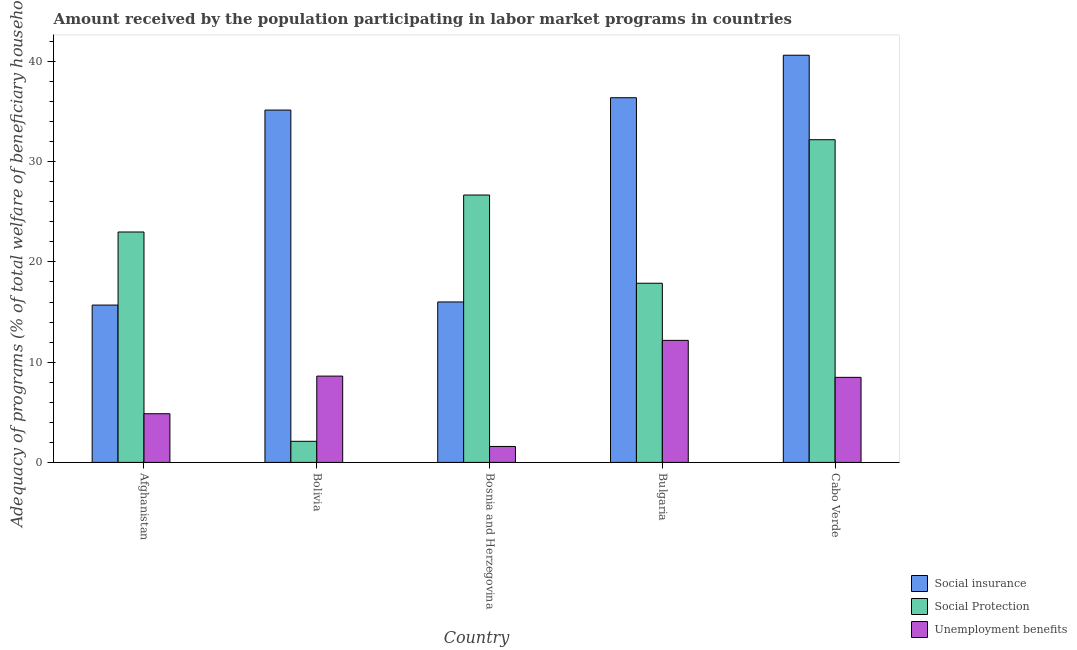Are the number of bars per tick equal to the number of legend labels?
Keep it short and to the point. Yes. How many bars are there on the 4th tick from the left?
Ensure brevity in your answer.  3. How many bars are there on the 1st tick from the right?
Ensure brevity in your answer.  3. What is the label of the 4th group of bars from the left?
Give a very brief answer. Bulgaria. What is the amount received by the population participating in social protection programs in Bulgaria?
Give a very brief answer. 17.87. Across all countries, what is the maximum amount received by the population participating in unemployment benefits programs?
Your answer should be compact. 12.17. Across all countries, what is the minimum amount received by the population participating in social protection programs?
Keep it short and to the point. 2.1. In which country was the amount received by the population participating in social protection programs maximum?
Give a very brief answer. Cabo Verde. In which country was the amount received by the population participating in social insurance programs minimum?
Give a very brief answer. Afghanistan. What is the total amount received by the population participating in social insurance programs in the graph?
Make the answer very short. 143.85. What is the difference between the amount received by the population participating in social protection programs in Bolivia and that in Bosnia and Herzegovina?
Your answer should be very brief. -24.57. What is the difference between the amount received by the population participating in social protection programs in Bolivia and the amount received by the population participating in social insurance programs in Bosnia and Herzegovina?
Your answer should be very brief. -13.9. What is the average amount received by the population participating in social protection programs per country?
Keep it short and to the point. 20.37. What is the difference between the amount received by the population participating in unemployment benefits programs and amount received by the population participating in social insurance programs in Bosnia and Herzegovina?
Keep it short and to the point. -14.42. In how many countries, is the amount received by the population participating in unemployment benefits programs greater than 18 %?
Offer a very short reply. 0. What is the ratio of the amount received by the population participating in unemployment benefits programs in Bosnia and Herzegovina to that in Bulgaria?
Keep it short and to the point. 0.13. What is the difference between the highest and the second highest amount received by the population participating in social protection programs?
Provide a succinct answer. 5.52. What is the difference between the highest and the lowest amount received by the population participating in social protection programs?
Your answer should be compact. 30.09. In how many countries, is the amount received by the population participating in social protection programs greater than the average amount received by the population participating in social protection programs taken over all countries?
Provide a short and direct response. 3. Is the sum of the amount received by the population participating in unemployment benefits programs in Afghanistan and Cabo Verde greater than the maximum amount received by the population participating in social protection programs across all countries?
Give a very brief answer. No. What does the 2nd bar from the left in Cabo Verde represents?
Offer a very short reply. Social Protection. What does the 3rd bar from the right in Bolivia represents?
Offer a terse response. Social insurance. How many bars are there?
Offer a terse response. 15. How many countries are there in the graph?
Your answer should be compact. 5. Are the values on the major ticks of Y-axis written in scientific E-notation?
Keep it short and to the point. No. Does the graph contain any zero values?
Give a very brief answer. No. Does the graph contain grids?
Offer a very short reply. No. Where does the legend appear in the graph?
Provide a short and direct response. Bottom right. What is the title of the graph?
Your answer should be compact. Amount received by the population participating in labor market programs in countries. What is the label or title of the Y-axis?
Your answer should be very brief. Adequacy of programs (% of total welfare of beneficiary households). What is the Adequacy of programs (% of total welfare of beneficiary households) of Social insurance in Afghanistan?
Give a very brief answer. 15.7. What is the Adequacy of programs (% of total welfare of beneficiary households) in Social Protection in Afghanistan?
Make the answer very short. 22.99. What is the Adequacy of programs (% of total welfare of beneficiary households) in Unemployment benefits in Afghanistan?
Your response must be concise. 4.86. What is the Adequacy of programs (% of total welfare of beneficiary households) of Social insurance in Bolivia?
Provide a short and direct response. 35.15. What is the Adequacy of programs (% of total welfare of beneficiary households) of Social Protection in Bolivia?
Provide a short and direct response. 2.1. What is the Adequacy of programs (% of total welfare of beneficiary households) of Unemployment benefits in Bolivia?
Provide a short and direct response. 8.61. What is the Adequacy of programs (% of total welfare of beneficiary households) of Social insurance in Bosnia and Herzegovina?
Offer a very short reply. 16.01. What is the Adequacy of programs (% of total welfare of beneficiary households) of Social Protection in Bosnia and Herzegovina?
Make the answer very short. 26.67. What is the Adequacy of programs (% of total welfare of beneficiary households) in Unemployment benefits in Bosnia and Herzegovina?
Give a very brief answer. 1.59. What is the Adequacy of programs (% of total welfare of beneficiary households) of Social insurance in Bulgaria?
Offer a terse response. 36.38. What is the Adequacy of programs (% of total welfare of beneficiary households) in Social Protection in Bulgaria?
Ensure brevity in your answer.  17.87. What is the Adequacy of programs (% of total welfare of beneficiary households) of Unemployment benefits in Bulgaria?
Offer a very short reply. 12.17. What is the Adequacy of programs (% of total welfare of beneficiary households) of Social insurance in Cabo Verde?
Offer a very short reply. 40.62. What is the Adequacy of programs (% of total welfare of beneficiary households) of Social Protection in Cabo Verde?
Ensure brevity in your answer.  32.19. What is the Adequacy of programs (% of total welfare of beneficiary households) in Unemployment benefits in Cabo Verde?
Your answer should be very brief. 8.48. Across all countries, what is the maximum Adequacy of programs (% of total welfare of beneficiary households) of Social insurance?
Provide a succinct answer. 40.62. Across all countries, what is the maximum Adequacy of programs (% of total welfare of beneficiary households) of Social Protection?
Your answer should be compact. 32.19. Across all countries, what is the maximum Adequacy of programs (% of total welfare of beneficiary households) of Unemployment benefits?
Offer a very short reply. 12.17. Across all countries, what is the minimum Adequacy of programs (% of total welfare of beneficiary households) in Social insurance?
Your response must be concise. 15.7. Across all countries, what is the minimum Adequacy of programs (% of total welfare of beneficiary households) of Social Protection?
Give a very brief answer. 2.1. Across all countries, what is the minimum Adequacy of programs (% of total welfare of beneficiary households) of Unemployment benefits?
Ensure brevity in your answer.  1.59. What is the total Adequacy of programs (% of total welfare of beneficiary households) of Social insurance in the graph?
Ensure brevity in your answer.  143.85. What is the total Adequacy of programs (% of total welfare of beneficiary households) in Social Protection in the graph?
Offer a very short reply. 101.83. What is the total Adequacy of programs (% of total welfare of beneficiary households) of Unemployment benefits in the graph?
Give a very brief answer. 35.71. What is the difference between the Adequacy of programs (% of total welfare of beneficiary households) in Social insurance in Afghanistan and that in Bolivia?
Offer a terse response. -19.45. What is the difference between the Adequacy of programs (% of total welfare of beneficiary households) in Social Protection in Afghanistan and that in Bolivia?
Provide a succinct answer. 20.88. What is the difference between the Adequacy of programs (% of total welfare of beneficiary households) of Unemployment benefits in Afghanistan and that in Bolivia?
Offer a terse response. -3.75. What is the difference between the Adequacy of programs (% of total welfare of beneficiary households) in Social insurance in Afghanistan and that in Bosnia and Herzegovina?
Offer a very short reply. -0.31. What is the difference between the Adequacy of programs (% of total welfare of beneficiary households) of Social Protection in Afghanistan and that in Bosnia and Herzegovina?
Offer a very short reply. -3.69. What is the difference between the Adequacy of programs (% of total welfare of beneficiary households) of Unemployment benefits in Afghanistan and that in Bosnia and Herzegovina?
Your answer should be very brief. 3.27. What is the difference between the Adequacy of programs (% of total welfare of beneficiary households) of Social insurance in Afghanistan and that in Bulgaria?
Provide a short and direct response. -20.69. What is the difference between the Adequacy of programs (% of total welfare of beneficiary households) in Social Protection in Afghanistan and that in Bulgaria?
Your answer should be compact. 5.11. What is the difference between the Adequacy of programs (% of total welfare of beneficiary households) in Unemployment benefits in Afghanistan and that in Bulgaria?
Ensure brevity in your answer.  -7.32. What is the difference between the Adequacy of programs (% of total welfare of beneficiary households) of Social insurance in Afghanistan and that in Cabo Verde?
Offer a very short reply. -24.93. What is the difference between the Adequacy of programs (% of total welfare of beneficiary households) in Social Protection in Afghanistan and that in Cabo Verde?
Your answer should be compact. -9.21. What is the difference between the Adequacy of programs (% of total welfare of beneficiary households) in Unemployment benefits in Afghanistan and that in Cabo Verde?
Offer a terse response. -3.63. What is the difference between the Adequacy of programs (% of total welfare of beneficiary households) in Social insurance in Bolivia and that in Bosnia and Herzegovina?
Your answer should be very brief. 19.14. What is the difference between the Adequacy of programs (% of total welfare of beneficiary households) of Social Protection in Bolivia and that in Bosnia and Herzegovina?
Give a very brief answer. -24.57. What is the difference between the Adequacy of programs (% of total welfare of beneficiary households) in Unemployment benefits in Bolivia and that in Bosnia and Herzegovina?
Offer a terse response. 7.02. What is the difference between the Adequacy of programs (% of total welfare of beneficiary households) of Social insurance in Bolivia and that in Bulgaria?
Keep it short and to the point. -1.23. What is the difference between the Adequacy of programs (% of total welfare of beneficiary households) in Social Protection in Bolivia and that in Bulgaria?
Provide a short and direct response. -15.77. What is the difference between the Adequacy of programs (% of total welfare of beneficiary households) of Unemployment benefits in Bolivia and that in Bulgaria?
Give a very brief answer. -3.57. What is the difference between the Adequacy of programs (% of total welfare of beneficiary households) of Social insurance in Bolivia and that in Cabo Verde?
Make the answer very short. -5.47. What is the difference between the Adequacy of programs (% of total welfare of beneficiary households) of Social Protection in Bolivia and that in Cabo Verde?
Make the answer very short. -30.09. What is the difference between the Adequacy of programs (% of total welfare of beneficiary households) in Unemployment benefits in Bolivia and that in Cabo Verde?
Give a very brief answer. 0.12. What is the difference between the Adequacy of programs (% of total welfare of beneficiary households) of Social insurance in Bosnia and Herzegovina and that in Bulgaria?
Keep it short and to the point. -20.38. What is the difference between the Adequacy of programs (% of total welfare of beneficiary households) of Social Protection in Bosnia and Herzegovina and that in Bulgaria?
Your answer should be very brief. 8.8. What is the difference between the Adequacy of programs (% of total welfare of beneficiary households) in Unemployment benefits in Bosnia and Herzegovina and that in Bulgaria?
Make the answer very short. -10.59. What is the difference between the Adequacy of programs (% of total welfare of beneficiary households) in Social insurance in Bosnia and Herzegovina and that in Cabo Verde?
Your response must be concise. -24.61. What is the difference between the Adequacy of programs (% of total welfare of beneficiary households) of Social Protection in Bosnia and Herzegovina and that in Cabo Verde?
Offer a terse response. -5.52. What is the difference between the Adequacy of programs (% of total welfare of beneficiary households) of Unemployment benefits in Bosnia and Herzegovina and that in Cabo Verde?
Provide a succinct answer. -6.89. What is the difference between the Adequacy of programs (% of total welfare of beneficiary households) of Social insurance in Bulgaria and that in Cabo Verde?
Provide a succinct answer. -4.24. What is the difference between the Adequacy of programs (% of total welfare of beneficiary households) of Social Protection in Bulgaria and that in Cabo Verde?
Ensure brevity in your answer.  -14.32. What is the difference between the Adequacy of programs (% of total welfare of beneficiary households) in Unemployment benefits in Bulgaria and that in Cabo Verde?
Your response must be concise. 3.69. What is the difference between the Adequacy of programs (% of total welfare of beneficiary households) in Social insurance in Afghanistan and the Adequacy of programs (% of total welfare of beneficiary households) in Social Protection in Bolivia?
Provide a succinct answer. 13.59. What is the difference between the Adequacy of programs (% of total welfare of beneficiary households) of Social insurance in Afghanistan and the Adequacy of programs (% of total welfare of beneficiary households) of Unemployment benefits in Bolivia?
Provide a short and direct response. 7.09. What is the difference between the Adequacy of programs (% of total welfare of beneficiary households) of Social Protection in Afghanistan and the Adequacy of programs (% of total welfare of beneficiary households) of Unemployment benefits in Bolivia?
Keep it short and to the point. 14.38. What is the difference between the Adequacy of programs (% of total welfare of beneficiary households) in Social insurance in Afghanistan and the Adequacy of programs (% of total welfare of beneficiary households) in Social Protection in Bosnia and Herzegovina?
Offer a terse response. -10.98. What is the difference between the Adequacy of programs (% of total welfare of beneficiary households) in Social insurance in Afghanistan and the Adequacy of programs (% of total welfare of beneficiary households) in Unemployment benefits in Bosnia and Herzegovina?
Provide a short and direct response. 14.11. What is the difference between the Adequacy of programs (% of total welfare of beneficiary households) of Social Protection in Afghanistan and the Adequacy of programs (% of total welfare of beneficiary households) of Unemployment benefits in Bosnia and Herzegovina?
Your response must be concise. 21.4. What is the difference between the Adequacy of programs (% of total welfare of beneficiary households) in Social insurance in Afghanistan and the Adequacy of programs (% of total welfare of beneficiary households) in Social Protection in Bulgaria?
Keep it short and to the point. -2.18. What is the difference between the Adequacy of programs (% of total welfare of beneficiary households) in Social insurance in Afghanistan and the Adequacy of programs (% of total welfare of beneficiary households) in Unemployment benefits in Bulgaria?
Keep it short and to the point. 3.52. What is the difference between the Adequacy of programs (% of total welfare of beneficiary households) in Social Protection in Afghanistan and the Adequacy of programs (% of total welfare of beneficiary households) in Unemployment benefits in Bulgaria?
Offer a terse response. 10.81. What is the difference between the Adequacy of programs (% of total welfare of beneficiary households) in Social insurance in Afghanistan and the Adequacy of programs (% of total welfare of beneficiary households) in Social Protection in Cabo Verde?
Ensure brevity in your answer.  -16.5. What is the difference between the Adequacy of programs (% of total welfare of beneficiary households) in Social insurance in Afghanistan and the Adequacy of programs (% of total welfare of beneficiary households) in Unemployment benefits in Cabo Verde?
Offer a terse response. 7.21. What is the difference between the Adequacy of programs (% of total welfare of beneficiary households) in Social Protection in Afghanistan and the Adequacy of programs (% of total welfare of beneficiary households) in Unemployment benefits in Cabo Verde?
Your answer should be compact. 14.5. What is the difference between the Adequacy of programs (% of total welfare of beneficiary households) in Social insurance in Bolivia and the Adequacy of programs (% of total welfare of beneficiary households) in Social Protection in Bosnia and Herzegovina?
Give a very brief answer. 8.47. What is the difference between the Adequacy of programs (% of total welfare of beneficiary households) in Social insurance in Bolivia and the Adequacy of programs (% of total welfare of beneficiary households) in Unemployment benefits in Bosnia and Herzegovina?
Offer a very short reply. 33.56. What is the difference between the Adequacy of programs (% of total welfare of beneficiary households) in Social Protection in Bolivia and the Adequacy of programs (% of total welfare of beneficiary households) in Unemployment benefits in Bosnia and Herzegovina?
Ensure brevity in your answer.  0.51. What is the difference between the Adequacy of programs (% of total welfare of beneficiary households) in Social insurance in Bolivia and the Adequacy of programs (% of total welfare of beneficiary households) in Social Protection in Bulgaria?
Your answer should be very brief. 17.28. What is the difference between the Adequacy of programs (% of total welfare of beneficiary households) of Social insurance in Bolivia and the Adequacy of programs (% of total welfare of beneficiary households) of Unemployment benefits in Bulgaria?
Your response must be concise. 22.97. What is the difference between the Adequacy of programs (% of total welfare of beneficiary households) of Social Protection in Bolivia and the Adequacy of programs (% of total welfare of beneficiary households) of Unemployment benefits in Bulgaria?
Provide a succinct answer. -10.07. What is the difference between the Adequacy of programs (% of total welfare of beneficiary households) of Social insurance in Bolivia and the Adequacy of programs (% of total welfare of beneficiary households) of Social Protection in Cabo Verde?
Keep it short and to the point. 2.96. What is the difference between the Adequacy of programs (% of total welfare of beneficiary households) in Social insurance in Bolivia and the Adequacy of programs (% of total welfare of beneficiary households) in Unemployment benefits in Cabo Verde?
Give a very brief answer. 26.66. What is the difference between the Adequacy of programs (% of total welfare of beneficiary households) in Social Protection in Bolivia and the Adequacy of programs (% of total welfare of beneficiary households) in Unemployment benefits in Cabo Verde?
Your answer should be very brief. -6.38. What is the difference between the Adequacy of programs (% of total welfare of beneficiary households) of Social insurance in Bosnia and Herzegovina and the Adequacy of programs (% of total welfare of beneficiary households) of Social Protection in Bulgaria?
Offer a very short reply. -1.87. What is the difference between the Adequacy of programs (% of total welfare of beneficiary households) in Social insurance in Bosnia and Herzegovina and the Adequacy of programs (% of total welfare of beneficiary households) in Unemployment benefits in Bulgaria?
Provide a succinct answer. 3.83. What is the difference between the Adequacy of programs (% of total welfare of beneficiary households) of Social Protection in Bosnia and Herzegovina and the Adequacy of programs (% of total welfare of beneficiary households) of Unemployment benefits in Bulgaria?
Ensure brevity in your answer.  14.5. What is the difference between the Adequacy of programs (% of total welfare of beneficiary households) of Social insurance in Bosnia and Herzegovina and the Adequacy of programs (% of total welfare of beneficiary households) of Social Protection in Cabo Verde?
Offer a very short reply. -16.19. What is the difference between the Adequacy of programs (% of total welfare of beneficiary households) in Social insurance in Bosnia and Herzegovina and the Adequacy of programs (% of total welfare of beneficiary households) in Unemployment benefits in Cabo Verde?
Your answer should be very brief. 7.52. What is the difference between the Adequacy of programs (% of total welfare of beneficiary households) of Social Protection in Bosnia and Herzegovina and the Adequacy of programs (% of total welfare of beneficiary households) of Unemployment benefits in Cabo Verde?
Your response must be concise. 18.19. What is the difference between the Adequacy of programs (% of total welfare of beneficiary households) in Social insurance in Bulgaria and the Adequacy of programs (% of total welfare of beneficiary households) in Social Protection in Cabo Verde?
Give a very brief answer. 4.19. What is the difference between the Adequacy of programs (% of total welfare of beneficiary households) of Social insurance in Bulgaria and the Adequacy of programs (% of total welfare of beneficiary households) of Unemployment benefits in Cabo Verde?
Make the answer very short. 27.9. What is the difference between the Adequacy of programs (% of total welfare of beneficiary households) in Social Protection in Bulgaria and the Adequacy of programs (% of total welfare of beneficiary households) in Unemployment benefits in Cabo Verde?
Offer a very short reply. 9.39. What is the average Adequacy of programs (% of total welfare of beneficiary households) of Social insurance per country?
Ensure brevity in your answer.  28.77. What is the average Adequacy of programs (% of total welfare of beneficiary households) in Social Protection per country?
Your answer should be compact. 20.37. What is the average Adequacy of programs (% of total welfare of beneficiary households) in Unemployment benefits per country?
Keep it short and to the point. 7.14. What is the difference between the Adequacy of programs (% of total welfare of beneficiary households) of Social insurance and Adequacy of programs (% of total welfare of beneficiary households) of Social Protection in Afghanistan?
Your answer should be compact. -7.29. What is the difference between the Adequacy of programs (% of total welfare of beneficiary households) in Social insurance and Adequacy of programs (% of total welfare of beneficiary households) in Unemployment benefits in Afghanistan?
Provide a short and direct response. 10.84. What is the difference between the Adequacy of programs (% of total welfare of beneficiary households) of Social Protection and Adequacy of programs (% of total welfare of beneficiary households) of Unemployment benefits in Afghanistan?
Provide a short and direct response. 18.13. What is the difference between the Adequacy of programs (% of total welfare of beneficiary households) of Social insurance and Adequacy of programs (% of total welfare of beneficiary households) of Social Protection in Bolivia?
Your answer should be compact. 33.05. What is the difference between the Adequacy of programs (% of total welfare of beneficiary households) in Social insurance and Adequacy of programs (% of total welfare of beneficiary households) in Unemployment benefits in Bolivia?
Provide a succinct answer. 26.54. What is the difference between the Adequacy of programs (% of total welfare of beneficiary households) in Social Protection and Adequacy of programs (% of total welfare of beneficiary households) in Unemployment benefits in Bolivia?
Your answer should be very brief. -6.51. What is the difference between the Adequacy of programs (% of total welfare of beneficiary households) of Social insurance and Adequacy of programs (% of total welfare of beneficiary households) of Social Protection in Bosnia and Herzegovina?
Offer a very short reply. -10.67. What is the difference between the Adequacy of programs (% of total welfare of beneficiary households) of Social insurance and Adequacy of programs (% of total welfare of beneficiary households) of Unemployment benefits in Bosnia and Herzegovina?
Your response must be concise. 14.42. What is the difference between the Adequacy of programs (% of total welfare of beneficiary households) of Social Protection and Adequacy of programs (% of total welfare of beneficiary households) of Unemployment benefits in Bosnia and Herzegovina?
Your response must be concise. 25.09. What is the difference between the Adequacy of programs (% of total welfare of beneficiary households) in Social insurance and Adequacy of programs (% of total welfare of beneficiary households) in Social Protection in Bulgaria?
Ensure brevity in your answer.  18.51. What is the difference between the Adequacy of programs (% of total welfare of beneficiary households) of Social insurance and Adequacy of programs (% of total welfare of beneficiary households) of Unemployment benefits in Bulgaria?
Give a very brief answer. 24.21. What is the difference between the Adequacy of programs (% of total welfare of beneficiary households) in Social Protection and Adequacy of programs (% of total welfare of beneficiary households) in Unemployment benefits in Bulgaria?
Your response must be concise. 5.7. What is the difference between the Adequacy of programs (% of total welfare of beneficiary households) of Social insurance and Adequacy of programs (% of total welfare of beneficiary households) of Social Protection in Cabo Verde?
Keep it short and to the point. 8.43. What is the difference between the Adequacy of programs (% of total welfare of beneficiary households) of Social insurance and Adequacy of programs (% of total welfare of beneficiary households) of Unemployment benefits in Cabo Verde?
Give a very brief answer. 32.14. What is the difference between the Adequacy of programs (% of total welfare of beneficiary households) in Social Protection and Adequacy of programs (% of total welfare of beneficiary households) in Unemployment benefits in Cabo Verde?
Give a very brief answer. 23.71. What is the ratio of the Adequacy of programs (% of total welfare of beneficiary households) in Social insurance in Afghanistan to that in Bolivia?
Provide a succinct answer. 0.45. What is the ratio of the Adequacy of programs (% of total welfare of beneficiary households) in Social Protection in Afghanistan to that in Bolivia?
Ensure brevity in your answer.  10.93. What is the ratio of the Adequacy of programs (% of total welfare of beneficiary households) of Unemployment benefits in Afghanistan to that in Bolivia?
Offer a very short reply. 0.56. What is the ratio of the Adequacy of programs (% of total welfare of beneficiary households) of Social insurance in Afghanistan to that in Bosnia and Herzegovina?
Your answer should be compact. 0.98. What is the ratio of the Adequacy of programs (% of total welfare of beneficiary households) in Social Protection in Afghanistan to that in Bosnia and Herzegovina?
Your answer should be compact. 0.86. What is the ratio of the Adequacy of programs (% of total welfare of beneficiary households) of Unemployment benefits in Afghanistan to that in Bosnia and Herzegovina?
Keep it short and to the point. 3.06. What is the ratio of the Adequacy of programs (% of total welfare of beneficiary households) in Social insurance in Afghanistan to that in Bulgaria?
Offer a terse response. 0.43. What is the ratio of the Adequacy of programs (% of total welfare of beneficiary households) in Social Protection in Afghanistan to that in Bulgaria?
Keep it short and to the point. 1.29. What is the ratio of the Adequacy of programs (% of total welfare of beneficiary households) of Unemployment benefits in Afghanistan to that in Bulgaria?
Give a very brief answer. 0.4. What is the ratio of the Adequacy of programs (% of total welfare of beneficiary households) of Social insurance in Afghanistan to that in Cabo Verde?
Offer a terse response. 0.39. What is the ratio of the Adequacy of programs (% of total welfare of beneficiary households) in Social Protection in Afghanistan to that in Cabo Verde?
Offer a very short reply. 0.71. What is the ratio of the Adequacy of programs (% of total welfare of beneficiary households) of Unemployment benefits in Afghanistan to that in Cabo Verde?
Your response must be concise. 0.57. What is the ratio of the Adequacy of programs (% of total welfare of beneficiary households) in Social insurance in Bolivia to that in Bosnia and Herzegovina?
Ensure brevity in your answer.  2.2. What is the ratio of the Adequacy of programs (% of total welfare of beneficiary households) of Social Protection in Bolivia to that in Bosnia and Herzegovina?
Your answer should be compact. 0.08. What is the ratio of the Adequacy of programs (% of total welfare of beneficiary households) in Unemployment benefits in Bolivia to that in Bosnia and Herzegovina?
Ensure brevity in your answer.  5.42. What is the ratio of the Adequacy of programs (% of total welfare of beneficiary households) of Social insurance in Bolivia to that in Bulgaria?
Provide a short and direct response. 0.97. What is the ratio of the Adequacy of programs (% of total welfare of beneficiary households) of Social Protection in Bolivia to that in Bulgaria?
Your answer should be compact. 0.12. What is the ratio of the Adequacy of programs (% of total welfare of beneficiary households) in Unemployment benefits in Bolivia to that in Bulgaria?
Make the answer very short. 0.71. What is the ratio of the Adequacy of programs (% of total welfare of beneficiary households) in Social insurance in Bolivia to that in Cabo Verde?
Keep it short and to the point. 0.87. What is the ratio of the Adequacy of programs (% of total welfare of beneficiary households) of Social Protection in Bolivia to that in Cabo Verde?
Offer a terse response. 0.07. What is the ratio of the Adequacy of programs (% of total welfare of beneficiary households) of Unemployment benefits in Bolivia to that in Cabo Verde?
Your response must be concise. 1.01. What is the ratio of the Adequacy of programs (% of total welfare of beneficiary households) of Social insurance in Bosnia and Herzegovina to that in Bulgaria?
Offer a very short reply. 0.44. What is the ratio of the Adequacy of programs (% of total welfare of beneficiary households) of Social Protection in Bosnia and Herzegovina to that in Bulgaria?
Your response must be concise. 1.49. What is the ratio of the Adequacy of programs (% of total welfare of beneficiary households) of Unemployment benefits in Bosnia and Herzegovina to that in Bulgaria?
Give a very brief answer. 0.13. What is the ratio of the Adequacy of programs (% of total welfare of beneficiary households) of Social insurance in Bosnia and Herzegovina to that in Cabo Verde?
Make the answer very short. 0.39. What is the ratio of the Adequacy of programs (% of total welfare of beneficiary households) in Social Protection in Bosnia and Herzegovina to that in Cabo Verde?
Your answer should be compact. 0.83. What is the ratio of the Adequacy of programs (% of total welfare of beneficiary households) in Unemployment benefits in Bosnia and Herzegovina to that in Cabo Verde?
Your answer should be compact. 0.19. What is the ratio of the Adequacy of programs (% of total welfare of beneficiary households) of Social insurance in Bulgaria to that in Cabo Verde?
Ensure brevity in your answer.  0.9. What is the ratio of the Adequacy of programs (% of total welfare of beneficiary households) of Social Protection in Bulgaria to that in Cabo Verde?
Provide a short and direct response. 0.56. What is the ratio of the Adequacy of programs (% of total welfare of beneficiary households) in Unemployment benefits in Bulgaria to that in Cabo Verde?
Give a very brief answer. 1.44. What is the difference between the highest and the second highest Adequacy of programs (% of total welfare of beneficiary households) of Social insurance?
Give a very brief answer. 4.24. What is the difference between the highest and the second highest Adequacy of programs (% of total welfare of beneficiary households) in Social Protection?
Provide a succinct answer. 5.52. What is the difference between the highest and the second highest Adequacy of programs (% of total welfare of beneficiary households) in Unemployment benefits?
Keep it short and to the point. 3.57. What is the difference between the highest and the lowest Adequacy of programs (% of total welfare of beneficiary households) of Social insurance?
Ensure brevity in your answer.  24.93. What is the difference between the highest and the lowest Adequacy of programs (% of total welfare of beneficiary households) in Social Protection?
Offer a terse response. 30.09. What is the difference between the highest and the lowest Adequacy of programs (% of total welfare of beneficiary households) of Unemployment benefits?
Offer a very short reply. 10.59. 